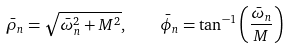<formula> <loc_0><loc_0><loc_500><loc_500>\bar { \rho } _ { n } = \sqrt { \bar { \omega } _ { n } ^ { 2 } + M ^ { 2 } } , \quad \bar { \phi } _ { n } = \tan ^ { - 1 } \left ( { \frac { \bar { \omega } _ { n } } { M } } \right )</formula> 